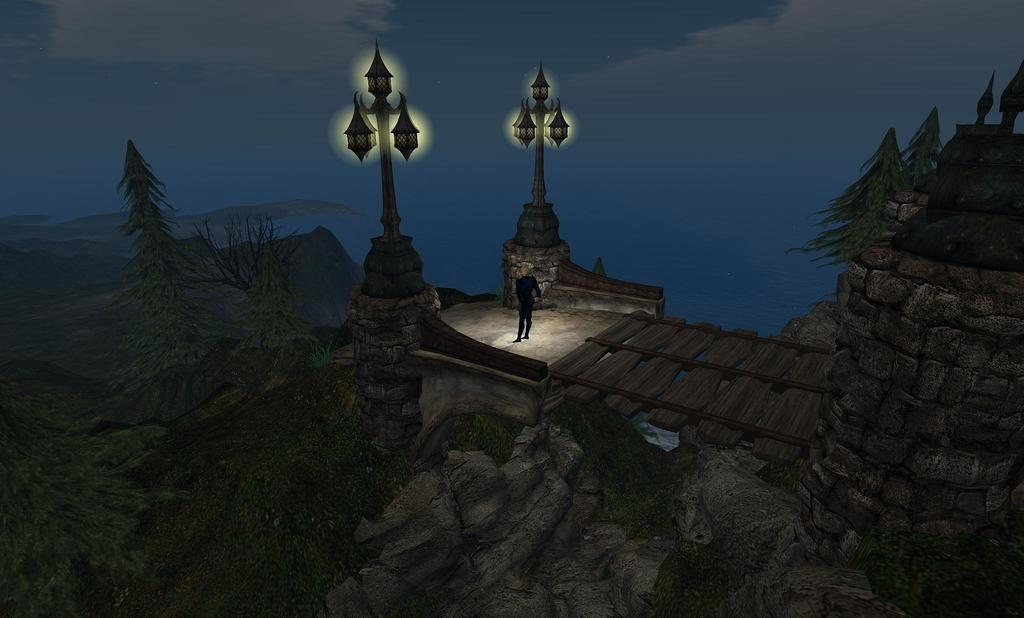What type of picture is in the image? The image contains an animation picture. What is happening in the animation? There is a person standing on a building in the animation. What type of natural elements are present in the animation? There are trees in the animation. What type of man-made structures are present in the animation? There are street light poles in the animation. How many chairs can be seen in the animation? There are no chairs present in the animation. What type of comb is being used by the person standing on the building? There is no comb visible in the animation, and the person standing on the building is not using any comb. 